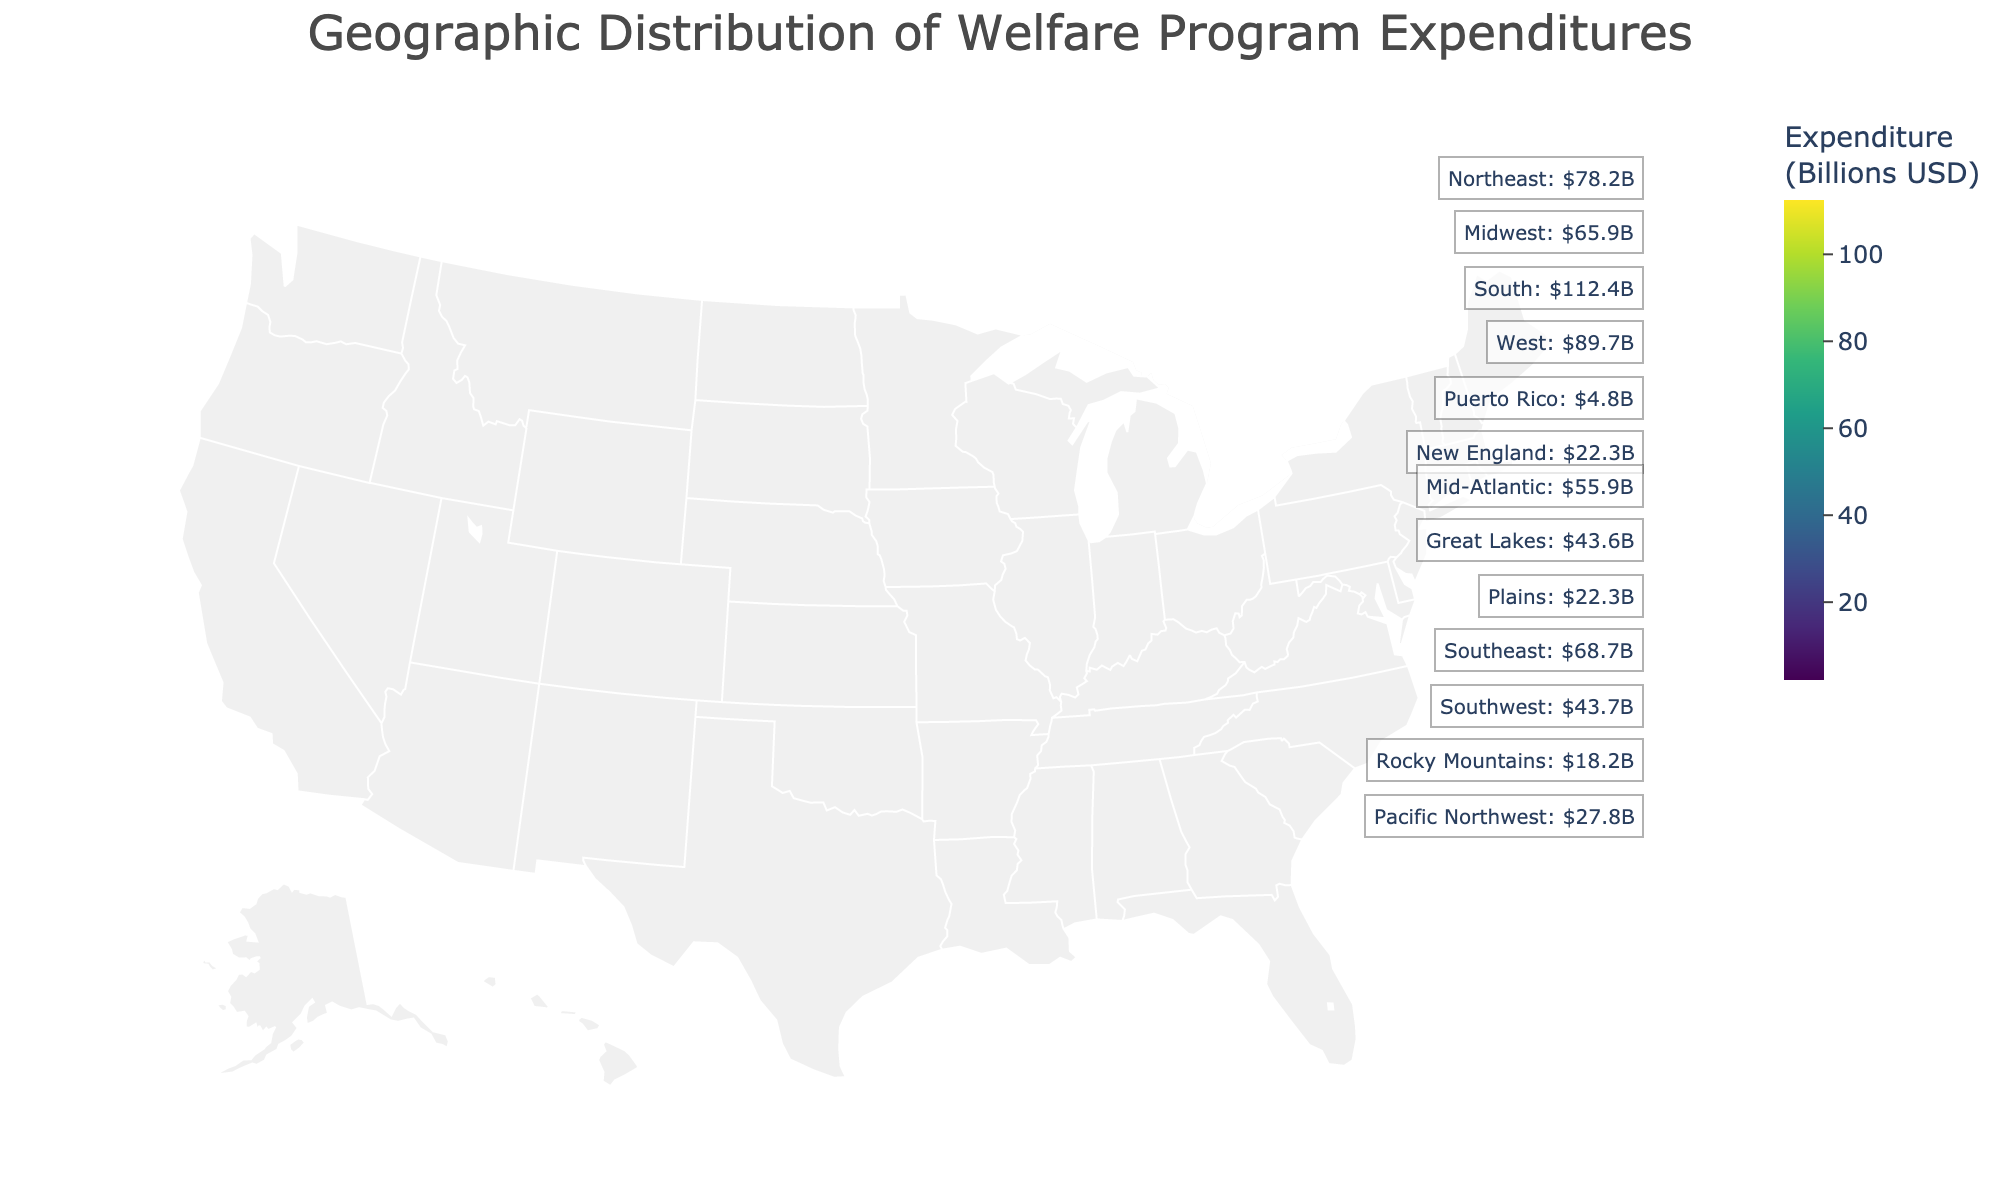How much is the welfare expenditure in California? You can directly look at the shaded region code (CA) on the map; the color intensity of California and the corresponding label indicate the expenditure.
Answer: 62.1 billion USD Which region has the highest welfare expenditure? By comparing the color intensities and labels of all regions, the South (South code) shows the highest value, with 112.4 billion USD.
Answer: South What is the total welfare expenditure for the regions in the West? Summing the expenditures for the regions marked as West (California, Pacific Northwest, Southwest, Rocky Mountains) results in 62.1 + 27.8 + 43.7 + 18.2 = 151.8 billion USD.
Answer: 151.8 billion USD Compare the welfare expenditures of the Northeast and the Midwest. Which one is higher and by how much? The Northeast has an expenditure of 78.2 billion USD, and the Midwest has 65.9 billion USD. The difference is 78.2 - 65.9 = 12.3 billion USD.
Answer: Northeast is higher by 12.3 billion USD Identify the region with the lowest welfare expenditure and provide its value. By checking the color and values of the regions, Alaska has the lowest expenditure at 2.1 billion USD.
Answer: Alaska, 2.1 billion USD How does the expenditure of the Southeast compare to that of the Northeast? The Southeast shows an expenditure of 68.7 billion USD, whereas the Northeast has 78.2 billion USD. The Northeast has a higher expenditure by 78.2 - 68.7 = 9.5 billion USD.
Answer: Northeast is higher by 9.5 billion USD What is the combined expenditure for Alaska, Hawaii, and Puerto Rico? Adding the expenditures of Alaska (2.1), Hawaii (3.5), and Puerto Rico (4.8) results in 2.1 + 3.5 + 4.8 = 10.4 billion USD.
Answer: 10.4 billion USD Which region has a higher welfare expenditure, Great Lakes or Pacific Northwest, and by how much? Great Lakes has an expenditure of 43.6 billion USD, while Pacific Northwest has 27.8 billion USD. The difference is 43.6 - 27.8 = 15.8 billion USD.
Answer: Great Lakes is higher by 15.8 billion USD 